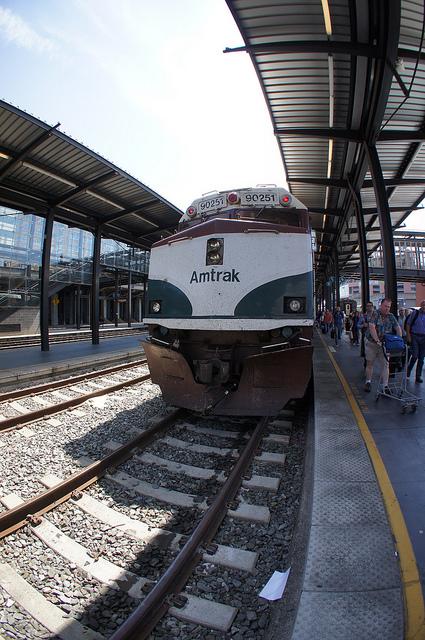Is this a busy train station?
Be succinct. Yes. What railway company owns this train?
Write a very short answer. Amtrak. What is the train on?
Write a very short answer. Track. 